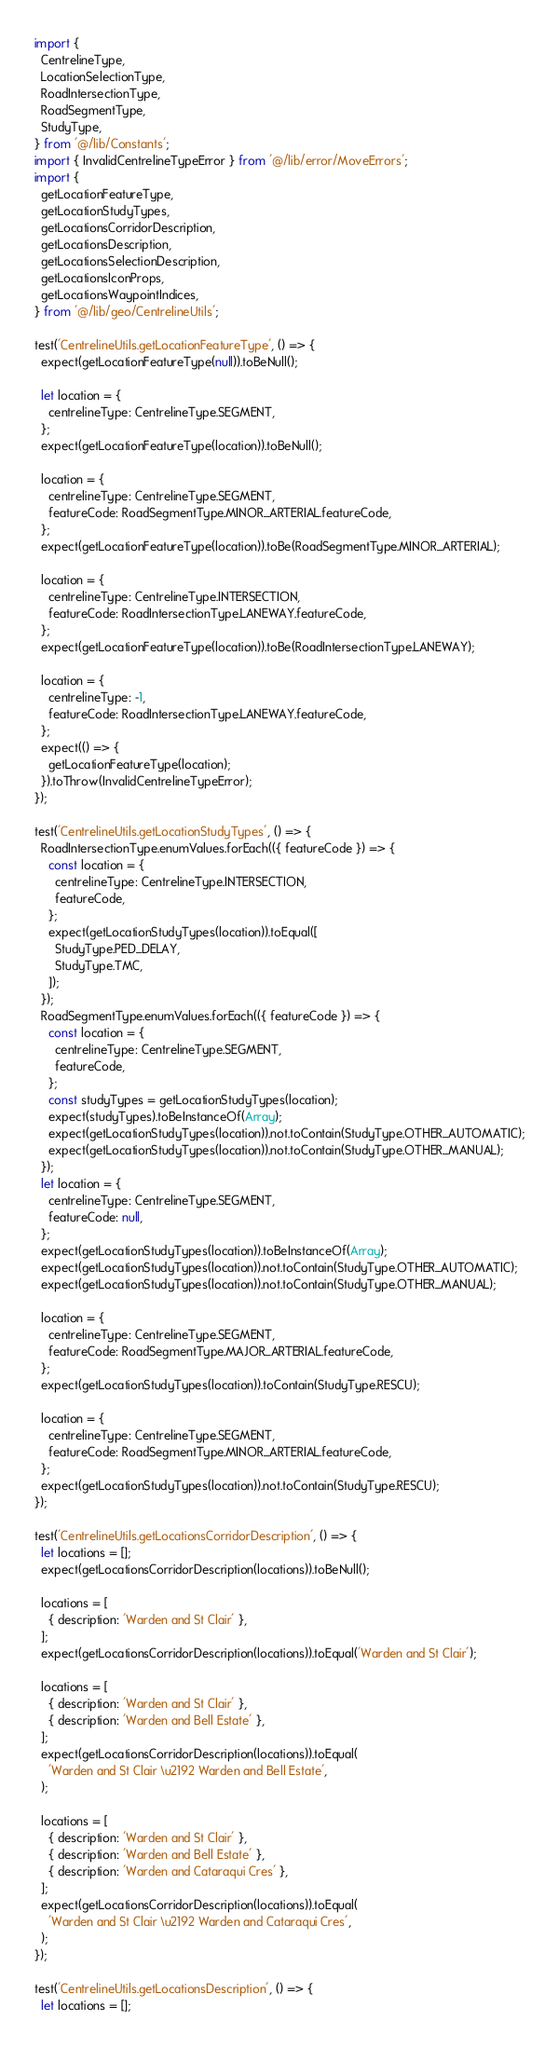Convert code to text. <code><loc_0><loc_0><loc_500><loc_500><_JavaScript_>import {
  CentrelineType,
  LocationSelectionType,
  RoadIntersectionType,
  RoadSegmentType,
  StudyType,
} from '@/lib/Constants';
import { InvalidCentrelineTypeError } from '@/lib/error/MoveErrors';
import {
  getLocationFeatureType,
  getLocationStudyTypes,
  getLocationsCorridorDescription,
  getLocationsDescription,
  getLocationsSelectionDescription,
  getLocationsIconProps,
  getLocationsWaypointIndices,
} from '@/lib/geo/CentrelineUtils';

test('CentrelineUtils.getLocationFeatureType', () => {
  expect(getLocationFeatureType(null)).toBeNull();

  let location = {
    centrelineType: CentrelineType.SEGMENT,
  };
  expect(getLocationFeatureType(location)).toBeNull();

  location = {
    centrelineType: CentrelineType.SEGMENT,
    featureCode: RoadSegmentType.MINOR_ARTERIAL.featureCode,
  };
  expect(getLocationFeatureType(location)).toBe(RoadSegmentType.MINOR_ARTERIAL);

  location = {
    centrelineType: CentrelineType.INTERSECTION,
    featureCode: RoadIntersectionType.LANEWAY.featureCode,
  };
  expect(getLocationFeatureType(location)).toBe(RoadIntersectionType.LANEWAY);

  location = {
    centrelineType: -1,
    featureCode: RoadIntersectionType.LANEWAY.featureCode,
  };
  expect(() => {
    getLocationFeatureType(location);
  }).toThrow(InvalidCentrelineTypeError);
});

test('CentrelineUtils.getLocationStudyTypes', () => {
  RoadIntersectionType.enumValues.forEach(({ featureCode }) => {
    const location = {
      centrelineType: CentrelineType.INTERSECTION,
      featureCode,
    };
    expect(getLocationStudyTypes(location)).toEqual([
      StudyType.PED_DELAY,
      StudyType.TMC,
    ]);
  });
  RoadSegmentType.enumValues.forEach(({ featureCode }) => {
    const location = {
      centrelineType: CentrelineType.SEGMENT,
      featureCode,
    };
    const studyTypes = getLocationStudyTypes(location);
    expect(studyTypes).toBeInstanceOf(Array);
    expect(getLocationStudyTypes(location)).not.toContain(StudyType.OTHER_AUTOMATIC);
    expect(getLocationStudyTypes(location)).not.toContain(StudyType.OTHER_MANUAL);
  });
  let location = {
    centrelineType: CentrelineType.SEGMENT,
    featureCode: null,
  };
  expect(getLocationStudyTypes(location)).toBeInstanceOf(Array);
  expect(getLocationStudyTypes(location)).not.toContain(StudyType.OTHER_AUTOMATIC);
  expect(getLocationStudyTypes(location)).not.toContain(StudyType.OTHER_MANUAL);

  location = {
    centrelineType: CentrelineType.SEGMENT,
    featureCode: RoadSegmentType.MAJOR_ARTERIAL.featureCode,
  };
  expect(getLocationStudyTypes(location)).toContain(StudyType.RESCU);

  location = {
    centrelineType: CentrelineType.SEGMENT,
    featureCode: RoadSegmentType.MINOR_ARTERIAL.featureCode,
  };
  expect(getLocationStudyTypes(location)).not.toContain(StudyType.RESCU);
});

test('CentrelineUtils.getLocationsCorridorDescription', () => {
  let locations = [];
  expect(getLocationsCorridorDescription(locations)).toBeNull();

  locations = [
    { description: 'Warden and St Clair' },
  ];
  expect(getLocationsCorridorDescription(locations)).toEqual('Warden and St Clair');

  locations = [
    { description: 'Warden and St Clair' },
    { description: 'Warden and Bell Estate' },
  ];
  expect(getLocationsCorridorDescription(locations)).toEqual(
    'Warden and St Clair \u2192 Warden and Bell Estate',
  );

  locations = [
    { description: 'Warden and St Clair' },
    { description: 'Warden and Bell Estate' },
    { description: 'Warden and Cataraqui Cres' },
  ];
  expect(getLocationsCorridorDescription(locations)).toEqual(
    'Warden and St Clair \u2192 Warden and Cataraqui Cres',
  );
});

test('CentrelineUtils.getLocationsDescription', () => {
  let locations = [];</code> 